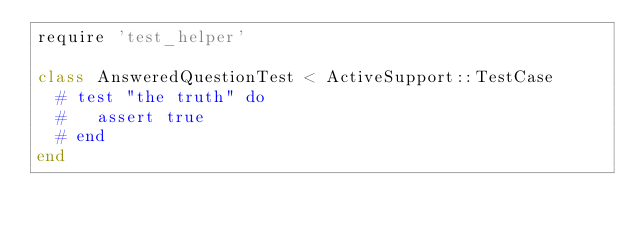Convert code to text. <code><loc_0><loc_0><loc_500><loc_500><_Ruby_>require 'test_helper'

class AnsweredQuestionTest < ActiveSupport::TestCase
  # test "the truth" do
  #   assert true
  # end
end
</code> 